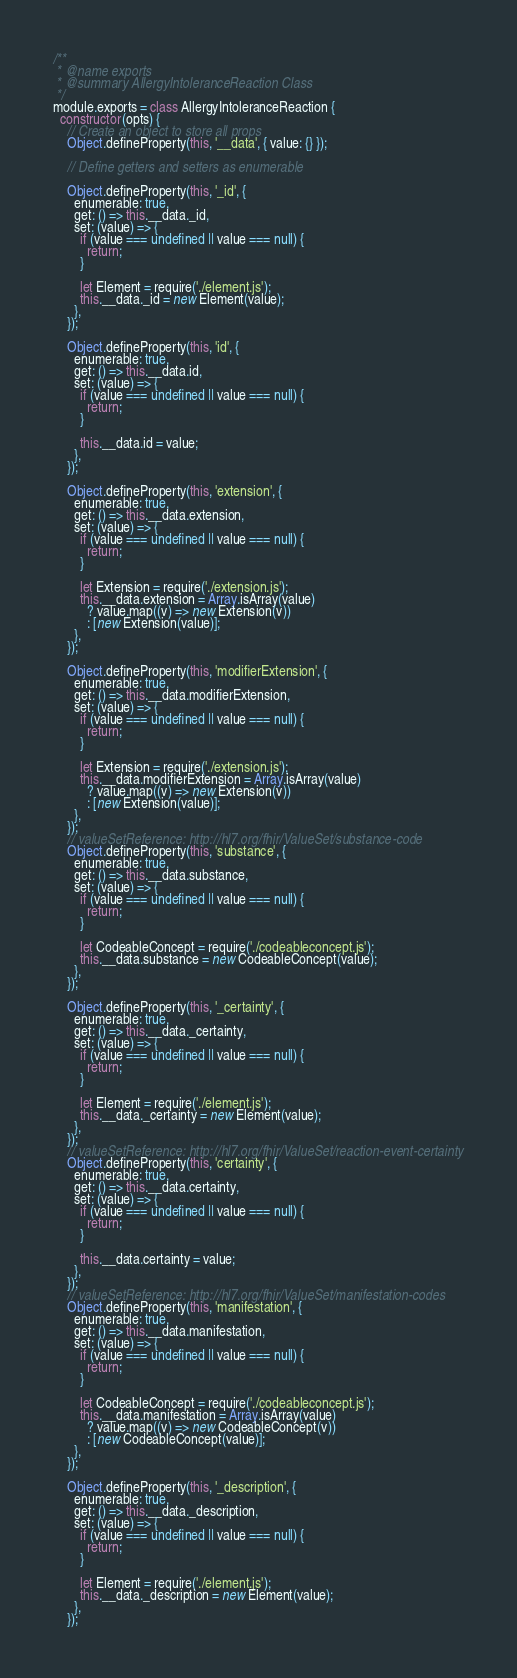<code> <loc_0><loc_0><loc_500><loc_500><_JavaScript_>/**
 * @name exports
 * @summary AllergyIntoleranceReaction Class
 */
module.exports = class AllergyIntoleranceReaction {
  constructor(opts) {
    // Create an object to store all props
    Object.defineProperty(this, '__data', { value: {} });

    // Define getters and setters as enumerable

    Object.defineProperty(this, '_id', {
      enumerable: true,
      get: () => this.__data._id,
      set: (value) => {
        if (value === undefined || value === null) {
          return;
        }

        let Element = require('./element.js');
        this.__data._id = new Element(value);
      },
    });

    Object.defineProperty(this, 'id', {
      enumerable: true,
      get: () => this.__data.id,
      set: (value) => {
        if (value === undefined || value === null) {
          return;
        }

        this.__data.id = value;
      },
    });

    Object.defineProperty(this, 'extension', {
      enumerable: true,
      get: () => this.__data.extension,
      set: (value) => {
        if (value === undefined || value === null) {
          return;
        }

        let Extension = require('./extension.js');
        this.__data.extension = Array.isArray(value)
          ? value.map((v) => new Extension(v))
          : [new Extension(value)];
      },
    });

    Object.defineProperty(this, 'modifierExtension', {
      enumerable: true,
      get: () => this.__data.modifierExtension,
      set: (value) => {
        if (value === undefined || value === null) {
          return;
        }

        let Extension = require('./extension.js');
        this.__data.modifierExtension = Array.isArray(value)
          ? value.map((v) => new Extension(v))
          : [new Extension(value)];
      },
    });
    // valueSetReference: http://hl7.org/fhir/ValueSet/substance-code
    Object.defineProperty(this, 'substance', {
      enumerable: true,
      get: () => this.__data.substance,
      set: (value) => {
        if (value === undefined || value === null) {
          return;
        }

        let CodeableConcept = require('./codeableconcept.js');
        this.__data.substance = new CodeableConcept(value);
      },
    });

    Object.defineProperty(this, '_certainty', {
      enumerable: true,
      get: () => this.__data._certainty,
      set: (value) => {
        if (value === undefined || value === null) {
          return;
        }

        let Element = require('./element.js');
        this.__data._certainty = new Element(value);
      },
    });
    // valueSetReference: http://hl7.org/fhir/ValueSet/reaction-event-certainty
    Object.defineProperty(this, 'certainty', {
      enumerable: true,
      get: () => this.__data.certainty,
      set: (value) => {
        if (value === undefined || value === null) {
          return;
        }

        this.__data.certainty = value;
      },
    });
    // valueSetReference: http://hl7.org/fhir/ValueSet/manifestation-codes
    Object.defineProperty(this, 'manifestation', {
      enumerable: true,
      get: () => this.__data.manifestation,
      set: (value) => {
        if (value === undefined || value === null) {
          return;
        }

        let CodeableConcept = require('./codeableconcept.js');
        this.__data.manifestation = Array.isArray(value)
          ? value.map((v) => new CodeableConcept(v))
          : [new CodeableConcept(value)];
      },
    });

    Object.defineProperty(this, '_description', {
      enumerable: true,
      get: () => this.__data._description,
      set: (value) => {
        if (value === undefined || value === null) {
          return;
        }

        let Element = require('./element.js');
        this.__data._description = new Element(value);
      },
    });
</code> 